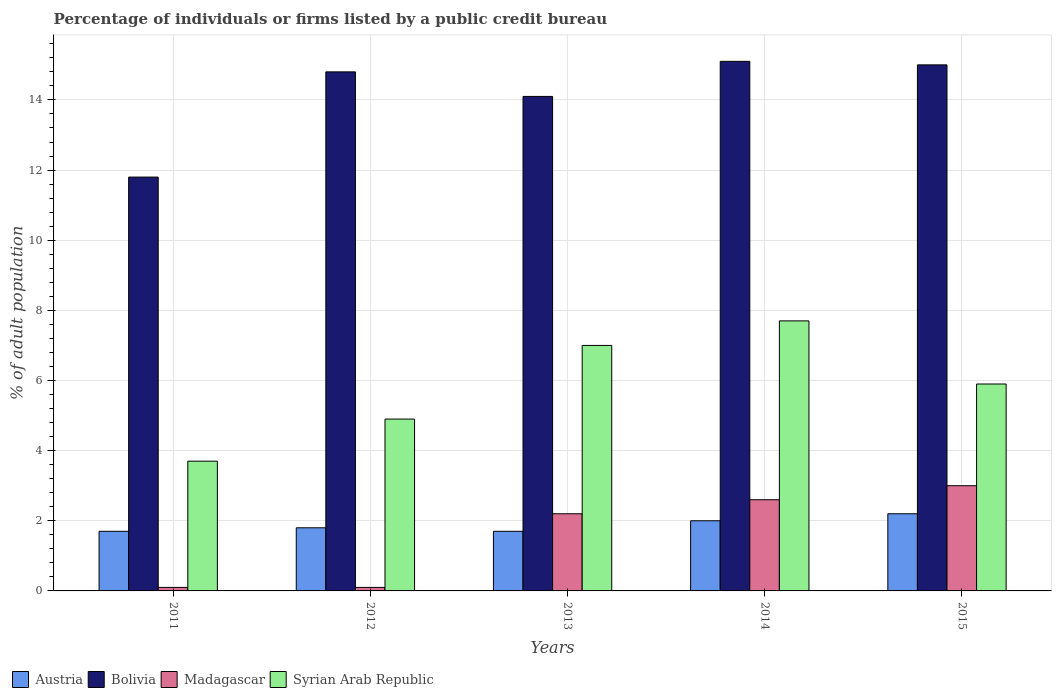How many groups of bars are there?
Give a very brief answer. 5. Are the number of bars per tick equal to the number of legend labels?
Offer a very short reply. Yes. How many bars are there on the 4th tick from the left?
Keep it short and to the point. 4. How many bars are there on the 4th tick from the right?
Make the answer very short. 4. What is the label of the 2nd group of bars from the left?
Your answer should be compact. 2012. In which year was the percentage of population listed by a public credit bureau in Austria maximum?
Your answer should be very brief. 2015. What is the total percentage of population listed by a public credit bureau in Syrian Arab Republic in the graph?
Keep it short and to the point. 29.2. What is the difference between the percentage of population listed by a public credit bureau in Syrian Arab Republic in 2012 and that in 2013?
Provide a short and direct response. -2.1. What is the difference between the percentage of population listed by a public credit bureau in Austria in 2015 and the percentage of population listed by a public credit bureau in Madagascar in 2012?
Provide a succinct answer. 2.1. In the year 2011, what is the difference between the percentage of population listed by a public credit bureau in Bolivia and percentage of population listed by a public credit bureau in Madagascar?
Keep it short and to the point. 11.7. What is the ratio of the percentage of population listed by a public credit bureau in Austria in 2011 to that in 2015?
Offer a terse response. 0.77. Is the difference between the percentage of population listed by a public credit bureau in Bolivia in 2014 and 2015 greater than the difference between the percentage of population listed by a public credit bureau in Madagascar in 2014 and 2015?
Offer a terse response. Yes. What is the difference between the highest and the second highest percentage of population listed by a public credit bureau in Syrian Arab Republic?
Offer a terse response. 0.7. What is the difference between the highest and the lowest percentage of population listed by a public credit bureau in Austria?
Offer a very short reply. 0.5. In how many years, is the percentage of population listed by a public credit bureau in Syrian Arab Republic greater than the average percentage of population listed by a public credit bureau in Syrian Arab Republic taken over all years?
Provide a succinct answer. 3. Is the sum of the percentage of population listed by a public credit bureau in Syrian Arab Republic in 2011 and 2013 greater than the maximum percentage of population listed by a public credit bureau in Austria across all years?
Offer a very short reply. Yes. Is it the case that in every year, the sum of the percentage of population listed by a public credit bureau in Madagascar and percentage of population listed by a public credit bureau in Syrian Arab Republic is greater than the sum of percentage of population listed by a public credit bureau in Bolivia and percentage of population listed by a public credit bureau in Austria?
Provide a succinct answer. No. What does the 1st bar from the right in 2014 represents?
Offer a terse response. Syrian Arab Republic. Are all the bars in the graph horizontal?
Offer a very short reply. No. How many years are there in the graph?
Give a very brief answer. 5. What is the difference between two consecutive major ticks on the Y-axis?
Ensure brevity in your answer.  2. Does the graph contain any zero values?
Offer a terse response. No. How many legend labels are there?
Provide a succinct answer. 4. What is the title of the graph?
Offer a very short reply. Percentage of individuals or firms listed by a public credit bureau. Does "Brazil" appear as one of the legend labels in the graph?
Your response must be concise. No. What is the label or title of the Y-axis?
Make the answer very short. % of adult population. What is the % of adult population in Madagascar in 2011?
Provide a short and direct response. 0.1. What is the % of adult population of Syrian Arab Republic in 2011?
Your answer should be compact. 3.7. What is the % of adult population in Syrian Arab Republic in 2012?
Offer a very short reply. 4.9. What is the % of adult population in Austria in 2013?
Your answer should be compact. 1.7. What is the % of adult population of Bolivia in 2013?
Give a very brief answer. 14.1. What is the % of adult population in Austria in 2014?
Keep it short and to the point. 2. What is the % of adult population of Austria in 2015?
Offer a terse response. 2.2. What is the % of adult population in Madagascar in 2015?
Your response must be concise. 3. Across all years, what is the maximum % of adult population in Syrian Arab Republic?
Provide a succinct answer. 7.7. Across all years, what is the minimum % of adult population of Austria?
Provide a short and direct response. 1.7. Across all years, what is the minimum % of adult population of Madagascar?
Ensure brevity in your answer.  0.1. Across all years, what is the minimum % of adult population in Syrian Arab Republic?
Make the answer very short. 3.7. What is the total % of adult population in Austria in the graph?
Make the answer very short. 9.4. What is the total % of adult population of Bolivia in the graph?
Keep it short and to the point. 70.8. What is the total % of adult population of Madagascar in the graph?
Provide a succinct answer. 8. What is the total % of adult population in Syrian Arab Republic in the graph?
Offer a terse response. 29.2. What is the difference between the % of adult population of Bolivia in 2011 and that in 2012?
Provide a short and direct response. -3. What is the difference between the % of adult population in Madagascar in 2011 and that in 2012?
Make the answer very short. 0. What is the difference between the % of adult population in Syrian Arab Republic in 2011 and that in 2012?
Offer a terse response. -1.2. What is the difference between the % of adult population of Syrian Arab Republic in 2011 and that in 2013?
Your answer should be very brief. -3.3. What is the difference between the % of adult population in Austria in 2011 and that in 2014?
Provide a succinct answer. -0.3. What is the difference between the % of adult population of Madagascar in 2011 and that in 2014?
Your response must be concise. -2.5. What is the difference between the % of adult population of Syrian Arab Republic in 2011 and that in 2014?
Your response must be concise. -4. What is the difference between the % of adult population of Bolivia in 2011 and that in 2015?
Your answer should be very brief. -3.2. What is the difference between the % of adult population in Austria in 2012 and that in 2013?
Make the answer very short. 0.1. What is the difference between the % of adult population of Syrian Arab Republic in 2012 and that in 2013?
Ensure brevity in your answer.  -2.1. What is the difference between the % of adult population of Austria in 2012 and that in 2015?
Your response must be concise. -0.4. What is the difference between the % of adult population in Madagascar in 2012 and that in 2015?
Make the answer very short. -2.9. What is the difference between the % of adult population in Bolivia in 2013 and that in 2014?
Keep it short and to the point. -1. What is the difference between the % of adult population of Syrian Arab Republic in 2013 and that in 2014?
Offer a very short reply. -0.7. What is the difference between the % of adult population in Bolivia in 2013 and that in 2015?
Your answer should be very brief. -0.9. What is the difference between the % of adult population of Madagascar in 2013 and that in 2015?
Offer a very short reply. -0.8. What is the difference between the % of adult population of Syrian Arab Republic in 2013 and that in 2015?
Your response must be concise. 1.1. What is the difference between the % of adult population of Austria in 2014 and that in 2015?
Provide a succinct answer. -0.2. What is the difference between the % of adult population of Syrian Arab Republic in 2014 and that in 2015?
Offer a very short reply. 1.8. What is the difference between the % of adult population of Austria in 2011 and the % of adult population of Bolivia in 2012?
Your response must be concise. -13.1. What is the difference between the % of adult population in Bolivia in 2011 and the % of adult population in Madagascar in 2012?
Make the answer very short. 11.7. What is the difference between the % of adult population of Austria in 2011 and the % of adult population of Bolivia in 2013?
Provide a succinct answer. -12.4. What is the difference between the % of adult population in Austria in 2011 and the % of adult population in Syrian Arab Republic in 2013?
Provide a short and direct response. -5.3. What is the difference between the % of adult population in Austria in 2011 and the % of adult population in Bolivia in 2014?
Your answer should be compact. -13.4. What is the difference between the % of adult population of Austria in 2011 and the % of adult population of Madagascar in 2014?
Offer a terse response. -0.9. What is the difference between the % of adult population in Bolivia in 2011 and the % of adult population in Syrian Arab Republic in 2014?
Ensure brevity in your answer.  4.1. What is the difference between the % of adult population of Austria in 2011 and the % of adult population of Bolivia in 2015?
Your response must be concise. -13.3. What is the difference between the % of adult population in Bolivia in 2011 and the % of adult population in Syrian Arab Republic in 2015?
Give a very brief answer. 5.9. What is the difference between the % of adult population in Madagascar in 2011 and the % of adult population in Syrian Arab Republic in 2015?
Your answer should be very brief. -5.8. What is the difference between the % of adult population in Austria in 2012 and the % of adult population in Bolivia in 2013?
Offer a very short reply. -12.3. What is the difference between the % of adult population of Bolivia in 2012 and the % of adult population of Syrian Arab Republic in 2013?
Provide a succinct answer. 7.8. What is the difference between the % of adult population of Madagascar in 2012 and the % of adult population of Syrian Arab Republic in 2013?
Offer a terse response. -6.9. What is the difference between the % of adult population of Austria in 2012 and the % of adult population of Bolivia in 2014?
Provide a short and direct response. -13.3. What is the difference between the % of adult population in Austria in 2012 and the % of adult population in Madagascar in 2014?
Give a very brief answer. -0.8. What is the difference between the % of adult population of Austria in 2012 and the % of adult population of Syrian Arab Republic in 2014?
Ensure brevity in your answer.  -5.9. What is the difference between the % of adult population in Austria in 2012 and the % of adult population in Madagascar in 2015?
Your answer should be compact. -1.2. What is the difference between the % of adult population in Austria in 2012 and the % of adult population in Syrian Arab Republic in 2015?
Provide a short and direct response. -4.1. What is the difference between the % of adult population in Madagascar in 2012 and the % of adult population in Syrian Arab Republic in 2015?
Ensure brevity in your answer.  -5.8. What is the difference between the % of adult population of Austria in 2013 and the % of adult population of Bolivia in 2014?
Keep it short and to the point. -13.4. What is the difference between the % of adult population of Austria in 2013 and the % of adult population of Syrian Arab Republic in 2014?
Your answer should be compact. -6. What is the difference between the % of adult population of Bolivia in 2013 and the % of adult population of Madagascar in 2014?
Make the answer very short. 11.5. What is the difference between the % of adult population in Bolivia in 2013 and the % of adult population in Syrian Arab Republic in 2014?
Make the answer very short. 6.4. What is the difference between the % of adult population in Austria in 2013 and the % of adult population in Madagascar in 2015?
Your response must be concise. -1.3. What is the difference between the % of adult population of Austria in 2013 and the % of adult population of Syrian Arab Republic in 2015?
Keep it short and to the point. -4.2. What is the difference between the % of adult population of Bolivia in 2013 and the % of adult population of Madagascar in 2015?
Provide a short and direct response. 11.1. What is the difference between the % of adult population of Bolivia in 2013 and the % of adult population of Syrian Arab Republic in 2015?
Provide a succinct answer. 8.2. What is the difference between the % of adult population of Madagascar in 2013 and the % of adult population of Syrian Arab Republic in 2015?
Make the answer very short. -3.7. What is the difference between the % of adult population in Austria in 2014 and the % of adult population in Bolivia in 2015?
Provide a succinct answer. -13. What is the difference between the % of adult population of Austria in 2014 and the % of adult population of Madagascar in 2015?
Your answer should be very brief. -1. What is the difference between the % of adult population of Bolivia in 2014 and the % of adult population of Syrian Arab Republic in 2015?
Provide a succinct answer. 9.2. What is the average % of adult population in Austria per year?
Your answer should be compact. 1.88. What is the average % of adult population in Bolivia per year?
Your response must be concise. 14.16. What is the average % of adult population in Madagascar per year?
Ensure brevity in your answer.  1.6. What is the average % of adult population of Syrian Arab Republic per year?
Ensure brevity in your answer.  5.84. In the year 2011, what is the difference between the % of adult population of Austria and % of adult population of Madagascar?
Offer a very short reply. 1.6. In the year 2011, what is the difference between the % of adult population of Bolivia and % of adult population of Madagascar?
Your answer should be compact. 11.7. In the year 2011, what is the difference between the % of adult population in Madagascar and % of adult population in Syrian Arab Republic?
Offer a very short reply. -3.6. In the year 2012, what is the difference between the % of adult population in Austria and % of adult population in Bolivia?
Offer a very short reply. -13. In the year 2012, what is the difference between the % of adult population of Austria and % of adult population of Syrian Arab Republic?
Offer a very short reply. -3.1. In the year 2012, what is the difference between the % of adult population in Madagascar and % of adult population in Syrian Arab Republic?
Provide a short and direct response. -4.8. In the year 2013, what is the difference between the % of adult population of Bolivia and % of adult population of Madagascar?
Make the answer very short. 11.9. In the year 2013, what is the difference between the % of adult population of Madagascar and % of adult population of Syrian Arab Republic?
Give a very brief answer. -4.8. In the year 2014, what is the difference between the % of adult population of Austria and % of adult population of Madagascar?
Your answer should be very brief. -0.6. In the year 2014, what is the difference between the % of adult population in Austria and % of adult population in Syrian Arab Republic?
Your answer should be compact. -5.7. In the year 2015, what is the difference between the % of adult population in Austria and % of adult population in Bolivia?
Give a very brief answer. -12.8. In the year 2015, what is the difference between the % of adult population in Bolivia and % of adult population in Syrian Arab Republic?
Provide a succinct answer. 9.1. What is the ratio of the % of adult population of Austria in 2011 to that in 2012?
Provide a short and direct response. 0.94. What is the ratio of the % of adult population in Bolivia in 2011 to that in 2012?
Give a very brief answer. 0.8. What is the ratio of the % of adult population of Syrian Arab Republic in 2011 to that in 2012?
Give a very brief answer. 0.76. What is the ratio of the % of adult population in Bolivia in 2011 to that in 2013?
Keep it short and to the point. 0.84. What is the ratio of the % of adult population in Madagascar in 2011 to that in 2013?
Provide a succinct answer. 0.05. What is the ratio of the % of adult population in Syrian Arab Republic in 2011 to that in 2013?
Ensure brevity in your answer.  0.53. What is the ratio of the % of adult population of Bolivia in 2011 to that in 2014?
Provide a short and direct response. 0.78. What is the ratio of the % of adult population in Madagascar in 2011 to that in 2014?
Make the answer very short. 0.04. What is the ratio of the % of adult population in Syrian Arab Republic in 2011 to that in 2014?
Make the answer very short. 0.48. What is the ratio of the % of adult population in Austria in 2011 to that in 2015?
Provide a short and direct response. 0.77. What is the ratio of the % of adult population in Bolivia in 2011 to that in 2015?
Offer a terse response. 0.79. What is the ratio of the % of adult population of Madagascar in 2011 to that in 2015?
Provide a short and direct response. 0.03. What is the ratio of the % of adult population of Syrian Arab Republic in 2011 to that in 2015?
Your response must be concise. 0.63. What is the ratio of the % of adult population of Austria in 2012 to that in 2013?
Give a very brief answer. 1.06. What is the ratio of the % of adult population in Bolivia in 2012 to that in 2013?
Offer a very short reply. 1.05. What is the ratio of the % of adult population in Madagascar in 2012 to that in 2013?
Your answer should be very brief. 0.05. What is the ratio of the % of adult population of Austria in 2012 to that in 2014?
Your answer should be compact. 0.9. What is the ratio of the % of adult population in Bolivia in 2012 to that in 2014?
Offer a very short reply. 0.98. What is the ratio of the % of adult population in Madagascar in 2012 to that in 2014?
Provide a succinct answer. 0.04. What is the ratio of the % of adult population in Syrian Arab Republic in 2012 to that in 2014?
Your response must be concise. 0.64. What is the ratio of the % of adult population in Austria in 2012 to that in 2015?
Make the answer very short. 0.82. What is the ratio of the % of adult population in Bolivia in 2012 to that in 2015?
Ensure brevity in your answer.  0.99. What is the ratio of the % of adult population of Syrian Arab Republic in 2012 to that in 2015?
Your answer should be very brief. 0.83. What is the ratio of the % of adult population of Austria in 2013 to that in 2014?
Give a very brief answer. 0.85. What is the ratio of the % of adult population in Bolivia in 2013 to that in 2014?
Your answer should be very brief. 0.93. What is the ratio of the % of adult population of Madagascar in 2013 to that in 2014?
Ensure brevity in your answer.  0.85. What is the ratio of the % of adult population in Syrian Arab Republic in 2013 to that in 2014?
Your response must be concise. 0.91. What is the ratio of the % of adult population of Austria in 2013 to that in 2015?
Make the answer very short. 0.77. What is the ratio of the % of adult population in Bolivia in 2013 to that in 2015?
Your response must be concise. 0.94. What is the ratio of the % of adult population of Madagascar in 2013 to that in 2015?
Give a very brief answer. 0.73. What is the ratio of the % of adult population in Syrian Arab Republic in 2013 to that in 2015?
Provide a succinct answer. 1.19. What is the ratio of the % of adult population of Austria in 2014 to that in 2015?
Your answer should be very brief. 0.91. What is the ratio of the % of adult population in Bolivia in 2014 to that in 2015?
Keep it short and to the point. 1.01. What is the ratio of the % of adult population in Madagascar in 2014 to that in 2015?
Make the answer very short. 0.87. What is the ratio of the % of adult population of Syrian Arab Republic in 2014 to that in 2015?
Make the answer very short. 1.31. What is the difference between the highest and the second highest % of adult population in Austria?
Make the answer very short. 0.2. What is the difference between the highest and the second highest % of adult population in Bolivia?
Your answer should be compact. 0.1. What is the difference between the highest and the lowest % of adult population of Austria?
Give a very brief answer. 0.5. What is the difference between the highest and the lowest % of adult population of Bolivia?
Your response must be concise. 3.3. What is the difference between the highest and the lowest % of adult population in Madagascar?
Your answer should be compact. 2.9. 